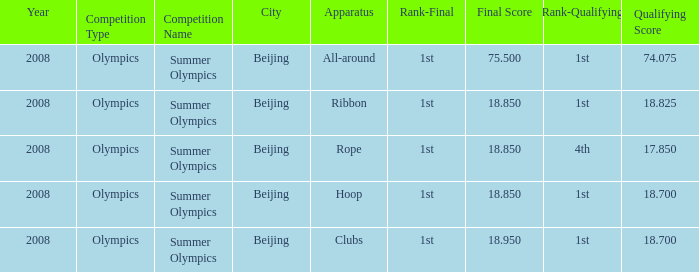On which apparatus did Kanayeva have a final score smaller than 75.5 and a qualifying score smaller than 18.7? Rope. 